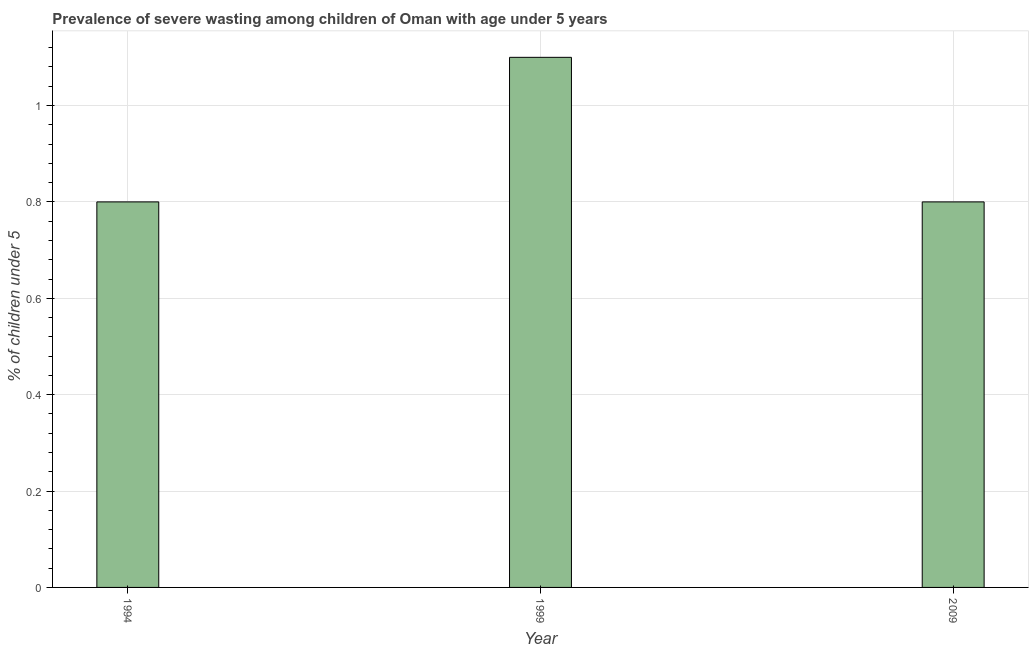Does the graph contain any zero values?
Provide a short and direct response. No. What is the title of the graph?
Offer a terse response. Prevalence of severe wasting among children of Oman with age under 5 years. What is the label or title of the Y-axis?
Keep it short and to the point.  % of children under 5. What is the prevalence of severe wasting in 1994?
Make the answer very short. 0.8. Across all years, what is the maximum prevalence of severe wasting?
Your answer should be compact. 1.1. Across all years, what is the minimum prevalence of severe wasting?
Offer a terse response. 0.8. What is the sum of the prevalence of severe wasting?
Your answer should be very brief. 2.7. What is the average prevalence of severe wasting per year?
Give a very brief answer. 0.9. What is the median prevalence of severe wasting?
Your answer should be very brief. 0.8. In how many years, is the prevalence of severe wasting greater than 0.92 %?
Keep it short and to the point. 1. Do a majority of the years between 1999 and 2009 (inclusive) have prevalence of severe wasting greater than 0.4 %?
Your response must be concise. Yes. What is the ratio of the prevalence of severe wasting in 1999 to that in 2009?
Ensure brevity in your answer.  1.38. What is the difference between the highest and the second highest prevalence of severe wasting?
Give a very brief answer. 0.3. Is the sum of the prevalence of severe wasting in 1994 and 2009 greater than the maximum prevalence of severe wasting across all years?
Offer a very short reply. Yes. In how many years, is the prevalence of severe wasting greater than the average prevalence of severe wasting taken over all years?
Your answer should be compact. 1. How many bars are there?
Ensure brevity in your answer.  3. Are all the bars in the graph horizontal?
Offer a terse response. No. Are the values on the major ticks of Y-axis written in scientific E-notation?
Your answer should be very brief. No. What is the  % of children under 5 in 1994?
Your response must be concise. 0.8. What is the  % of children under 5 of 1999?
Ensure brevity in your answer.  1.1. What is the  % of children under 5 in 2009?
Provide a short and direct response. 0.8. What is the difference between the  % of children under 5 in 1994 and 2009?
Your answer should be very brief. 0. What is the ratio of the  % of children under 5 in 1994 to that in 1999?
Provide a short and direct response. 0.73. What is the ratio of the  % of children under 5 in 1999 to that in 2009?
Your answer should be very brief. 1.38. 